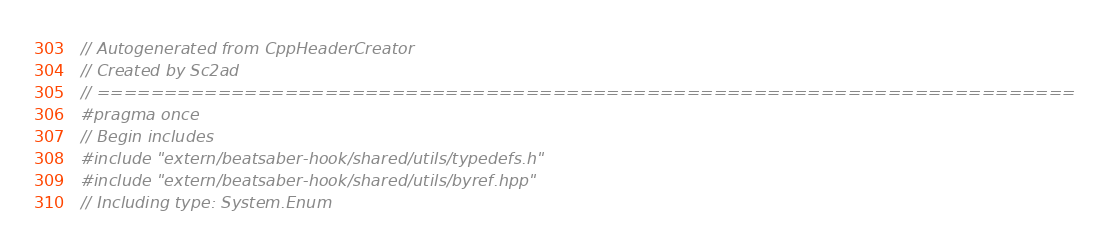<code> <loc_0><loc_0><loc_500><loc_500><_C++_>// Autogenerated from CppHeaderCreator
// Created by Sc2ad
// =========================================================================
#pragma once
// Begin includes
#include "extern/beatsaber-hook/shared/utils/typedefs.h"
#include "extern/beatsaber-hook/shared/utils/byref.hpp"
// Including type: System.Enum</code> 